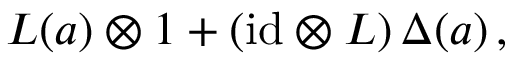Convert formula to latex. <formula><loc_0><loc_0><loc_500><loc_500>L ( a ) \otimes 1 + ( i d \otimes L ) \, \Delta ( a ) \, ,</formula> 